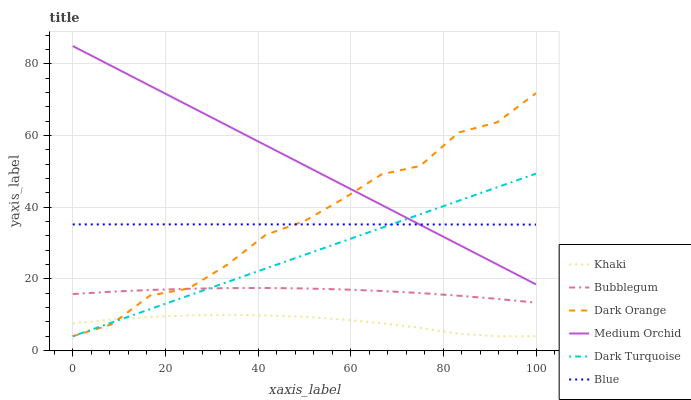Does Khaki have the minimum area under the curve?
Answer yes or no. Yes. Does Medium Orchid have the maximum area under the curve?
Answer yes or no. Yes. Does Dark Orange have the minimum area under the curve?
Answer yes or no. No. Does Dark Orange have the maximum area under the curve?
Answer yes or no. No. Is Dark Turquoise the smoothest?
Answer yes or no. Yes. Is Dark Orange the roughest?
Answer yes or no. Yes. Is Khaki the smoothest?
Answer yes or no. No. Is Khaki the roughest?
Answer yes or no. No. Does Medium Orchid have the lowest value?
Answer yes or no. No. Does Dark Orange have the highest value?
Answer yes or no. No. Is Khaki less than Medium Orchid?
Answer yes or no. Yes. Is Bubblegum greater than Khaki?
Answer yes or no. Yes. Does Khaki intersect Medium Orchid?
Answer yes or no. No. 